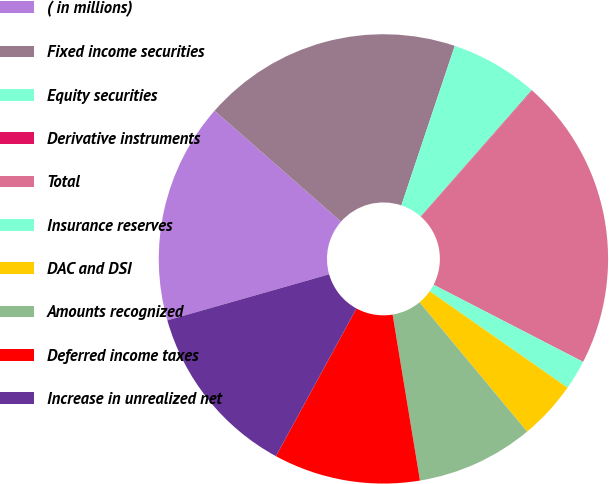Convert chart to OTSL. <chart><loc_0><loc_0><loc_500><loc_500><pie_chart><fcel>( in millions)<fcel>Fixed income securities<fcel>Equity securities<fcel>Derivative instruments<fcel>Total<fcel>Insurance reserves<fcel>DAC and DSI<fcel>Amounts recognized<fcel>Deferred income taxes<fcel>Increase in unrealized net<nl><fcel>15.87%<fcel>18.68%<fcel>6.34%<fcel>0.04%<fcel>21.05%<fcel>2.14%<fcel>4.24%<fcel>8.44%<fcel>10.54%<fcel>12.65%<nl></chart> 